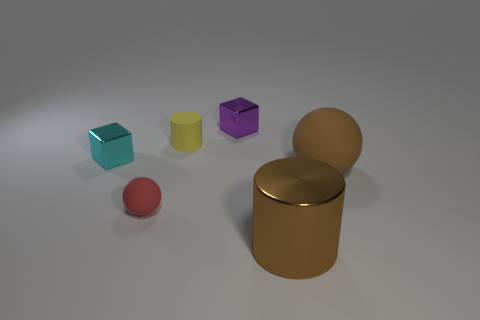There is a matte cylinder that is the same size as the red ball; what is its color?
Ensure brevity in your answer.  Yellow. There is a big thing that is the same color as the big sphere; what is its shape?
Provide a succinct answer. Cylinder. Do the small red object and the tiny yellow object have the same shape?
Provide a succinct answer. No. What is the material of the object that is to the right of the tiny red thing and in front of the large rubber object?
Your answer should be very brief. Metal. The brown metallic cylinder has what size?
Give a very brief answer. Large. There is another metal object that is the same shape as the tiny cyan object; what color is it?
Give a very brief answer. Purple. Is there any other thing that is the same color as the big ball?
Make the answer very short. Yes. There is a thing that is in front of the red rubber sphere; is its size the same as the shiny block behind the tiny yellow rubber cylinder?
Keep it short and to the point. No. Is the number of brown metal cylinders that are behind the tiny red object the same as the number of cyan shiny blocks that are on the right side of the yellow thing?
Give a very brief answer. Yes. Is the size of the cyan metal object the same as the rubber ball on the left side of the yellow thing?
Make the answer very short. Yes. 